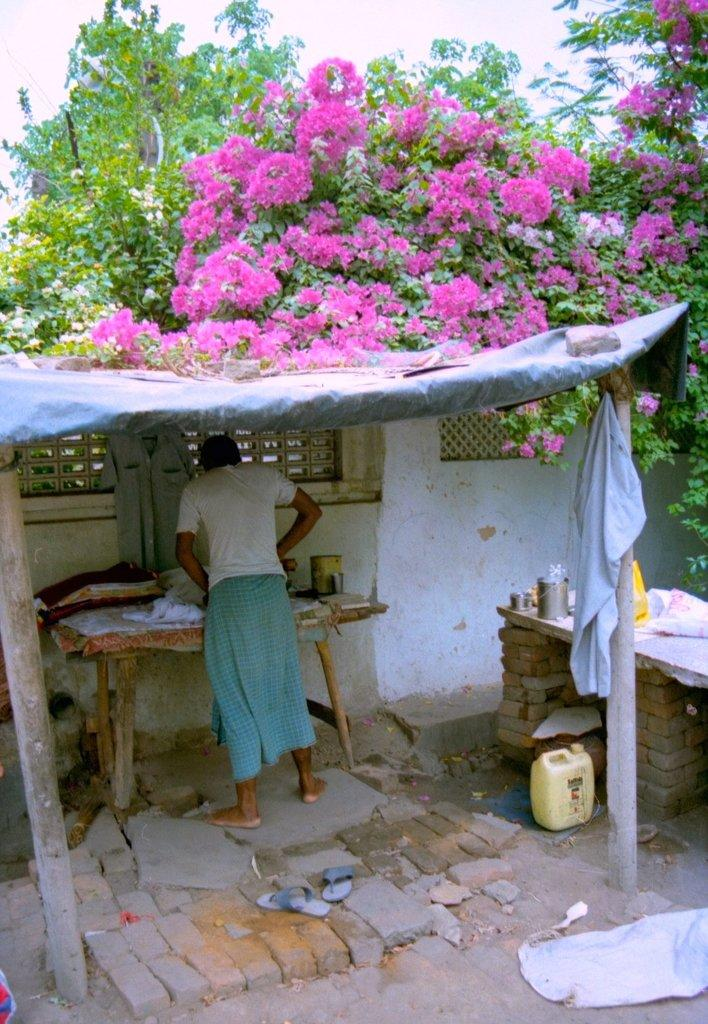What type of plant can be seen in the image? There is a tree in the image. Are there any other plants visible in the image? Yes, there are flowers in the image. Who is present in the image? There is a man standing in the image. What is in front of the man? There is a table in front of the man. What is on the table? There are clothes on the table. Can you see a snail crawling on the edge of the table in the image? There is no snail present in the image, and the edge of the table is not visible. 